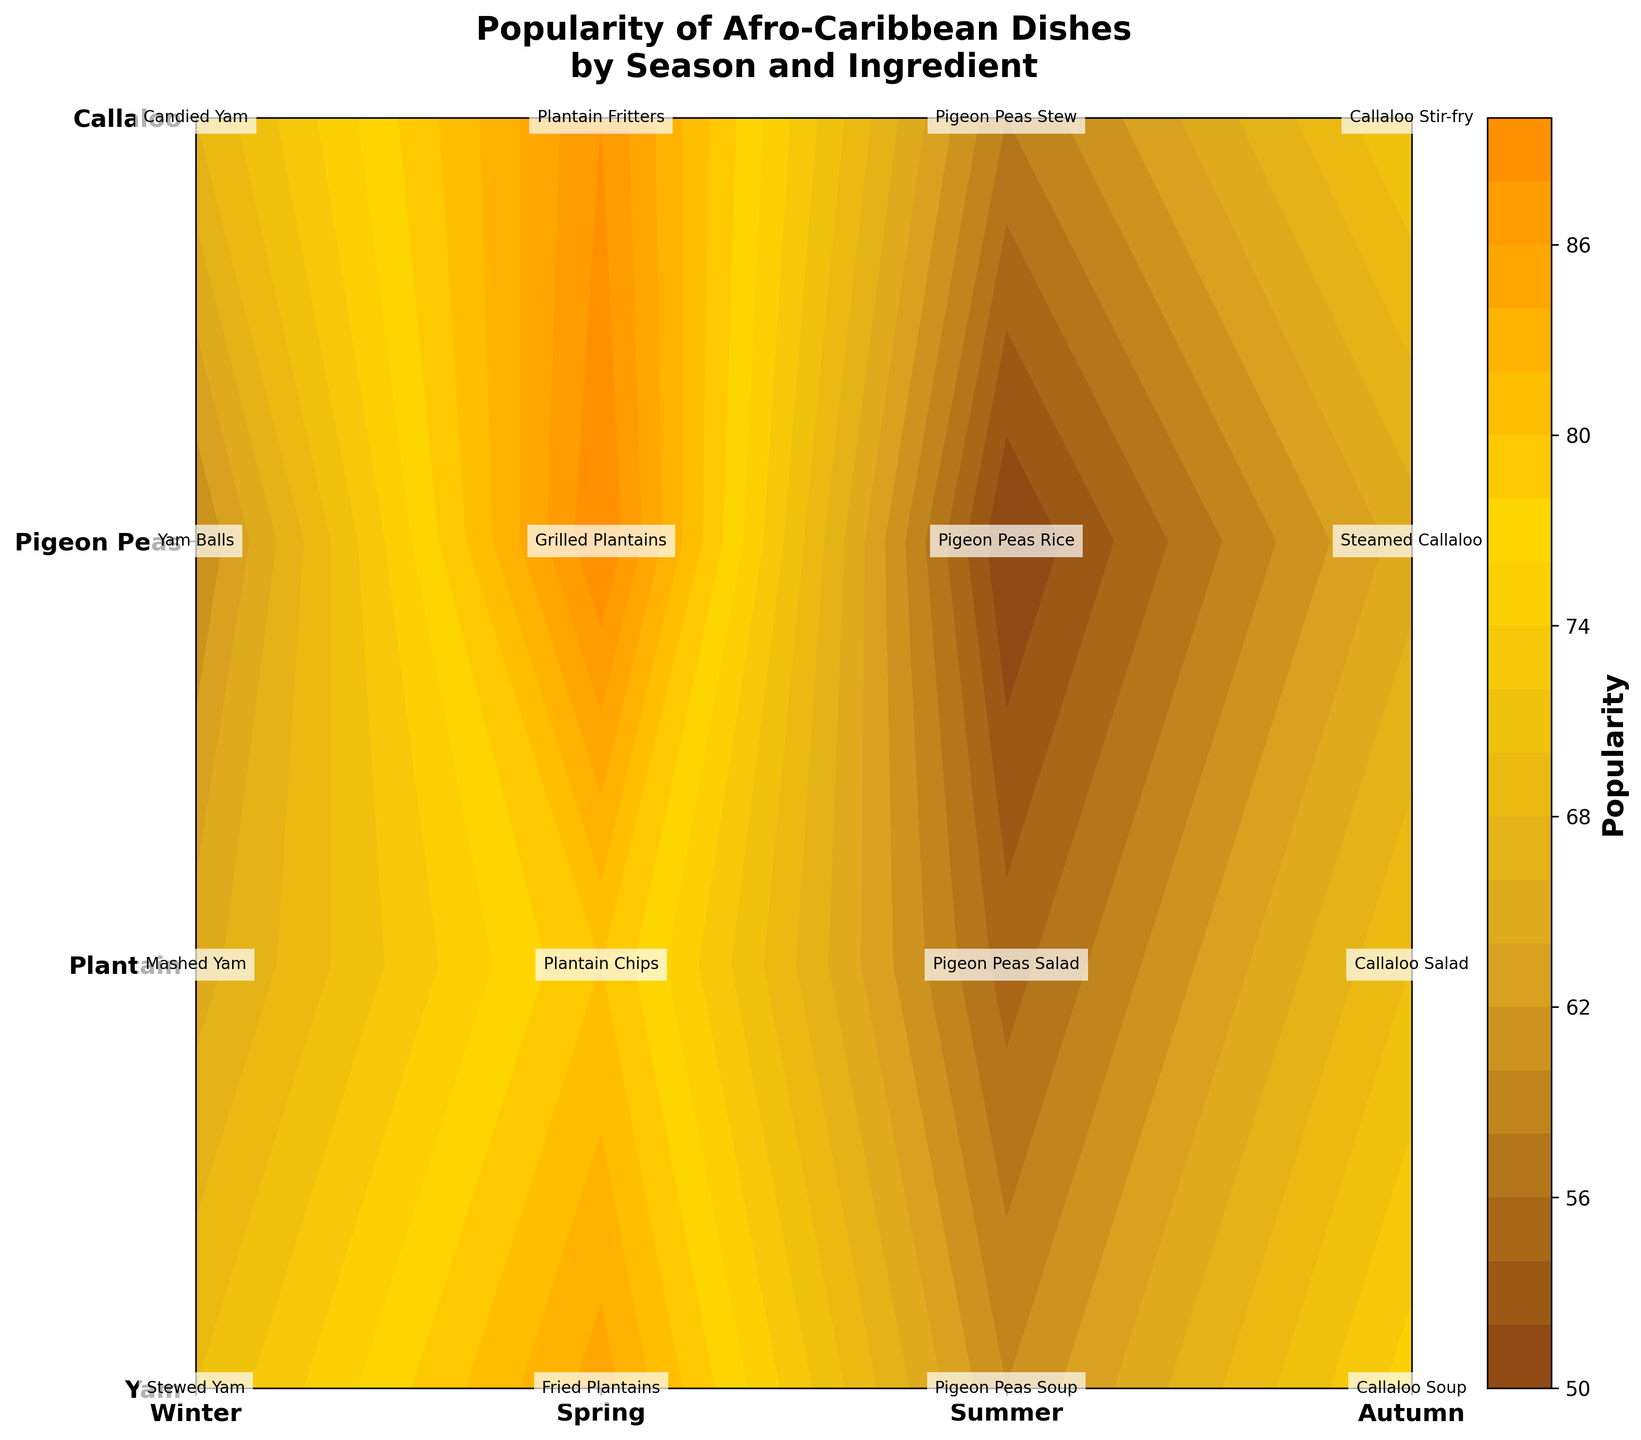Which season has the highest popularity for Plantain? The figure shows the popularity of each Afro-Caribbean dish for different seasons. By locating the section for Plantain and comparing the values, we see that "Grilled Plantains" in Summer has the highest popularity, which is at 90.
Answer: Summer What's the title of the figure? The title is usually found at the top of the plot. In this figure, the title given is "Popularity of Afro-Caribbean Dishes by Season and Ingredient".
Answer: Popularity of Afro-Caribbean Dishes by Season and Ingredient What is the color associated with the highest popularity range on the color bar? To determine this, we need to look at the color gradient on the color bar. The color associated with the highest end of the popularity scale is a dark brown color.
Answer: Dark brown Which dish has the least popularity in Spring? To find this, we compare the popularity values for Spring across all ingredients. The dish "Pigeon Peas Salad" has the lowest popularity at 55.
Answer: Pigeon Peas Salad List all Afro-Caribbean dishes that have a popularity rating of 70. We need to identify all points where the popularity is 70. "Callaloo Soup" (Winter), and "Callaloo Salad" (Spring), each have a popularity of 70.
Answer: Callaloo Soup, Callaloo Salad Compare the popularity of Stewed Yam in Winter and Candied Yam in Autumn. Which is higher? By looking at the values for Stewed Yam in Winter and Candied Yam in Autumn, we see that Stewed Yam has a popularity of 70, whereas Candied Yam has 68. Therefore, Stewed Yam has a slightly higher popularity.
Answer: Stewed Yam in Winter Is the popularity of Plantain increasing, decreasing, or fluctuating through the seasons? Observing the popularity values of dishes made from Plantain across the seasons: 85 (Winter), 80 (Spring), 90 (Summer), 88 (Autumn), we see that it does not consistently increase or decrease but rather fluctuates.
Answer: Fluctuating How many dishes have a popularity of over 80? By visually inspecting the contour plot for values greater than 80, we identify dishes with such popularity: 2- Fried Plantains (Winter) and Grilled Plantains (Summer).
Answer: 2 What ingredient has the lowest peak popularity and what is that popularity? Among all the ingredients, "Pigeon Peas" has the lowest peak popularity, with its highest value being 60 in Winter.
Answer: Pigeon Peas, 60 Which ingredient's popularity shows the least variation across the seasons? To determine this, we compare the popularity range for each ingredient across seasons. Callaloo shows the least variation with values of 75, 70, 65, and 72.
Answer: Callaloo 